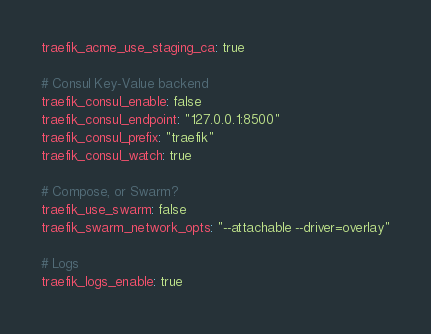Convert code to text. <code><loc_0><loc_0><loc_500><loc_500><_YAML_>traefik_acme_use_staging_ca: true

# Consul Key-Value backend
traefik_consul_enable: false
traefik_consul_endpoint: "127.0.0.1:8500"
traefik_consul_prefix: "traefik"
traefik_consul_watch: true

# Compose, or Swarm?
traefik_use_swarm: false
traefik_swarm_network_opts: "--attachable --driver=overlay"

# Logs
traefik_logs_enable: true
</code> 